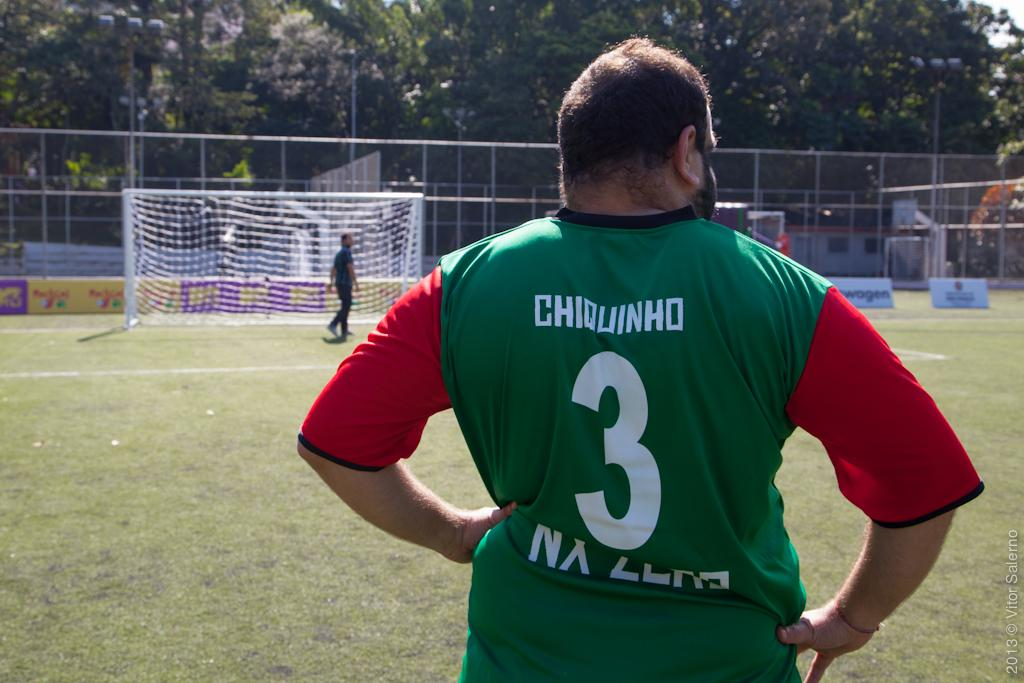<image>
Create a compact narrative representing the image presented. A man wearing a green number 3 jersey. 